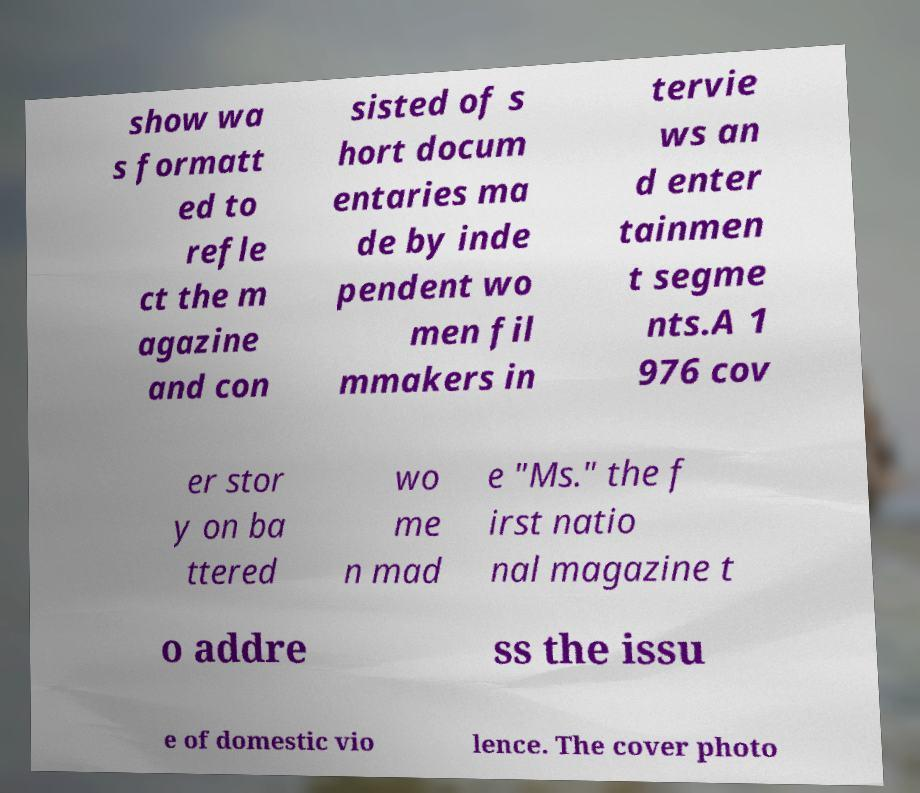For documentation purposes, I need the text within this image transcribed. Could you provide that? show wa s formatt ed to refle ct the m agazine and con sisted of s hort docum entaries ma de by inde pendent wo men fil mmakers in tervie ws an d enter tainmen t segme nts.A 1 976 cov er stor y on ba ttered wo me n mad e "Ms." the f irst natio nal magazine t o addre ss the issu e of domestic vio lence. The cover photo 